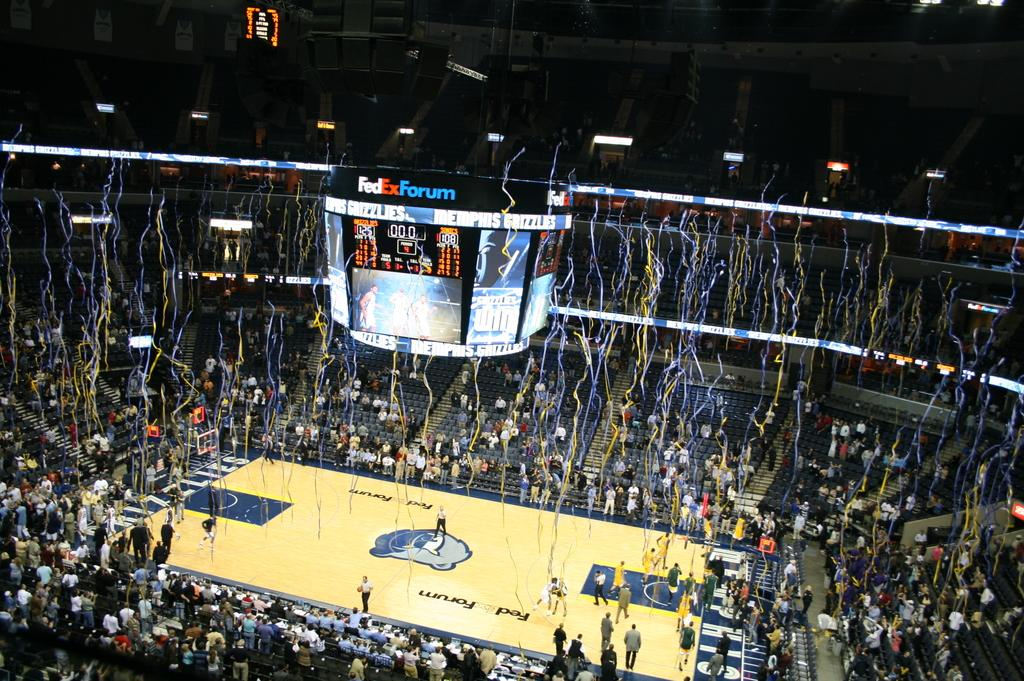<image>
Write a terse but informative summary of the picture. Screens hang above a court in a filled FedEx Forum. 